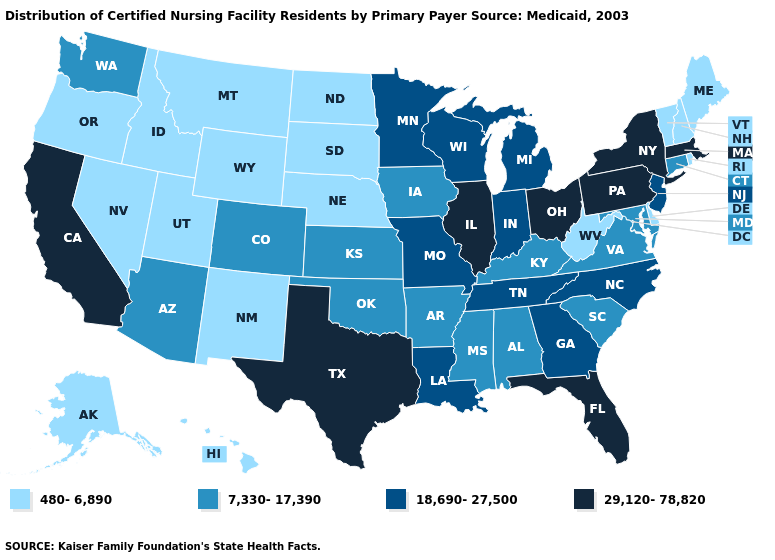Among the states that border Tennessee , does Georgia have the highest value?
Write a very short answer. Yes. Name the states that have a value in the range 18,690-27,500?
Be succinct. Georgia, Indiana, Louisiana, Michigan, Minnesota, Missouri, New Jersey, North Carolina, Tennessee, Wisconsin. Does the first symbol in the legend represent the smallest category?
Short answer required. Yes. Which states have the highest value in the USA?
Answer briefly. California, Florida, Illinois, Massachusetts, New York, Ohio, Pennsylvania, Texas. Which states have the lowest value in the South?
Give a very brief answer. Delaware, West Virginia. What is the value of Tennessee?
Short answer required. 18,690-27,500. Name the states that have a value in the range 29,120-78,820?
Give a very brief answer. California, Florida, Illinois, Massachusetts, New York, Ohio, Pennsylvania, Texas. Among the states that border Pennsylvania , does Ohio have the highest value?
Answer briefly. Yes. Does Kansas have a lower value than Nebraska?
Give a very brief answer. No. What is the lowest value in states that border North Dakota?
Keep it brief. 480-6,890. Which states have the lowest value in the USA?
Short answer required. Alaska, Delaware, Hawaii, Idaho, Maine, Montana, Nebraska, Nevada, New Hampshire, New Mexico, North Dakota, Oregon, Rhode Island, South Dakota, Utah, Vermont, West Virginia, Wyoming. Name the states that have a value in the range 480-6,890?
Give a very brief answer. Alaska, Delaware, Hawaii, Idaho, Maine, Montana, Nebraska, Nevada, New Hampshire, New Mexico, North Dakota, Oregon, Rhode Island, South Dakota, Utah, Vermont, West Virginia, Wyoming. Name the states that have a value in the range 480-6,890?
Short answer required. Alaska, Delaware, Hawaii, Idaho, Maine, Montana, Nebraska, Nevada, New Hampshire, New Mexico, North Dakota, Oregon, Rhode Island, South Dakota, Utah, Vermont, West Virginia, Wyoming. What is the value of Maine?
Quick response, please. 480-6,890. What is the value of South Carolina?
Write a very short answer. 7,330-17,390. 